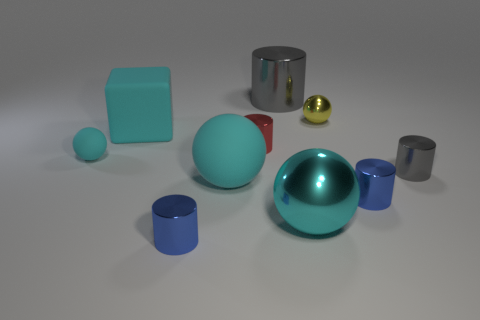Subtract all cyan blocks. How many cyan spheres are left? 3 Subtract all yellow cylinders. Subtract all green spheres. How many cylinders are left? 5 Subtract all cubes. How many objects are left? 9 Subtract all tiny gray metal objects. Subtract all tiny red metal objects. How many objects are left? 8 Add 1 tiny yellow spheres. How many tiny yellow spheres are left? 2 Add 1 yellow metallic objects. How many yellow metallic objects exist? 2 Subtract 0 red spheres. How many objects are left? 10 